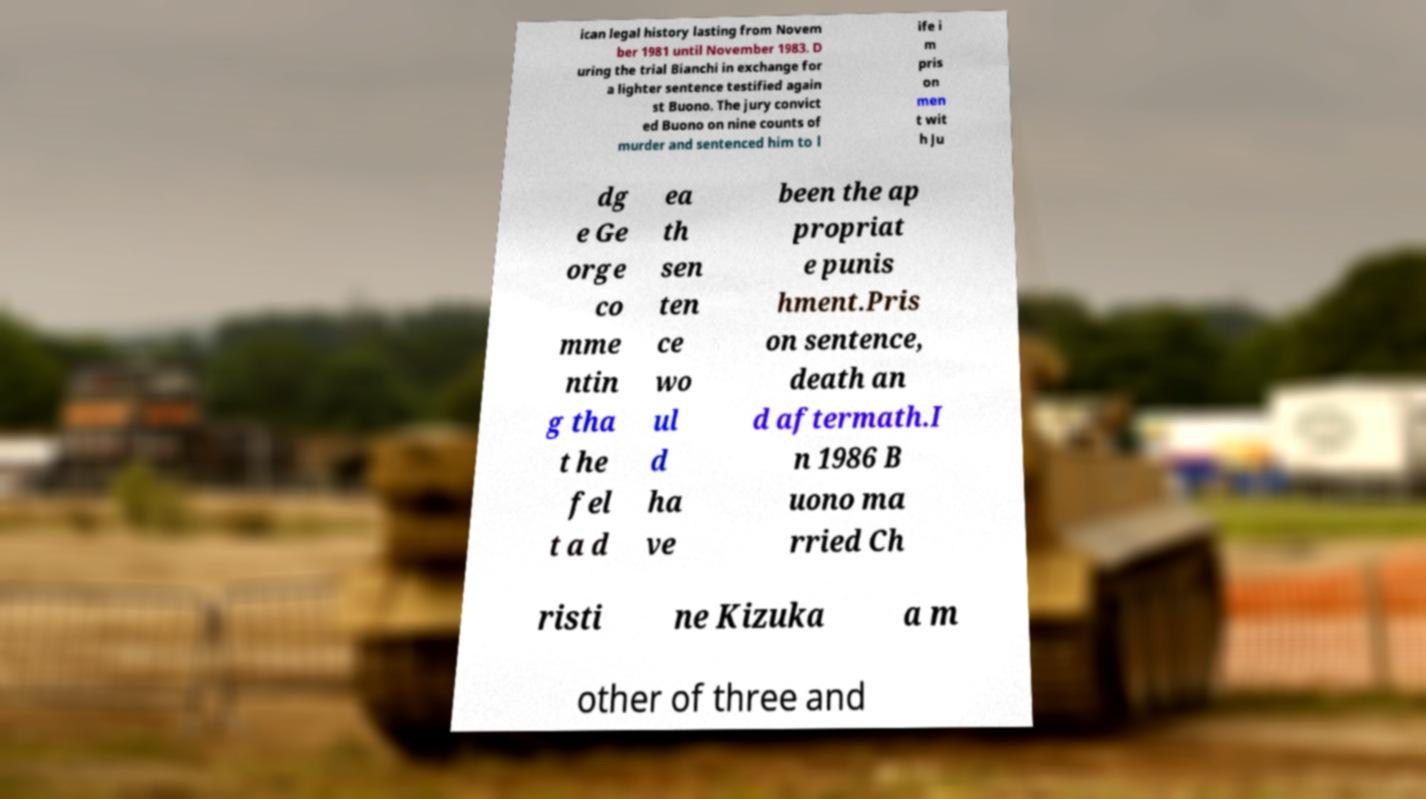There's text embedded in this image that I need extracted. Can you transcribe it verbatim? ican legal history lasting from Novem ber 1981 until November 1983. D uring the trial Bianchi in exchange for a lighter sentence testified again st Buono. The jury convict ed Buono on nine counts of murder and sentenced him to l ife i m pris on men t wit h Ju dg e Ge orge co mme ntin g tha t he fel t a d ea th sen ten ce wo ul d ha ve been the ap propriat e punis hment.Pris on sentence, death an d aftermath.I n 1986 B uono ma rried Ch risti ne Kizuka a m other of three and 